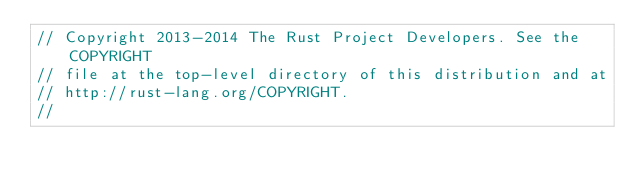Convert code to text. <code><loc_0><loc_0><loc_500><loc_500><_Rust_>// Copyright 2013-2014 The Rust Project Developers. See the COPYRIGHT
// file at the top-level directory of this distribution and at
// http://rust-lang.org/COPYRIGHT.
//</code> 